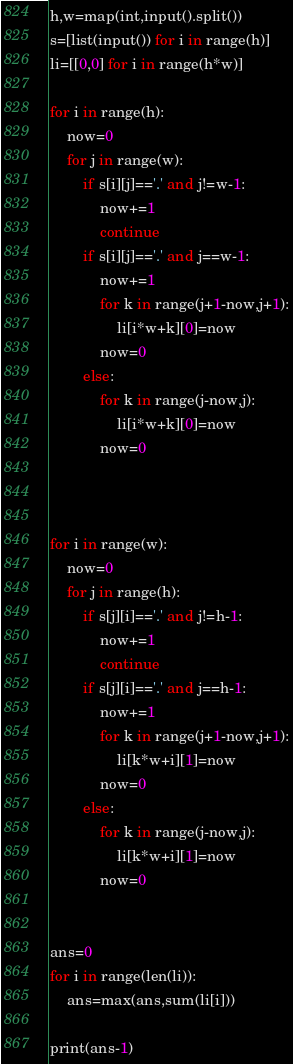Convert code to text. <code><loc_0><loc_0><loc_500><loc_500><_Python_>h,w=map(int,input().split())
s=[list(input()) for i in range(h)]
li=[[0,0] for i in range(h*w)]

for i in range(h):
    now=0
    for j in range(w):
        if s[i][j]=='.' and j!=w-1:
            now+=1
            continue
        if s[i][j]=='.' and j==w-1:
            now+=1
            for k in range(j+1-now,j+1):
                li[i*w+k][0]=now
            now=0
        else:
            for k in range(j-now,j):
                li[i*w+k][0]=now
            now=0



for i in range(w):
    now=0
    for j in range(h):
        if s[j][i]=='.' and j!=h-1:
            now+=1
            continue
        if s[j][i]=='.' and j==h-1:
            now+=1
            for k in range(j+1-now,j+1):
                li[k*w+i][1]=now
            now=0
        else:
            for k in range(j-now,j):
                li[k*w+i][1]=now
            now=0
  
    
ans=0    
for i in range(len(li)):
    ans=max(ans,sum(li[i]))
    
print(ans-1)
</code> 